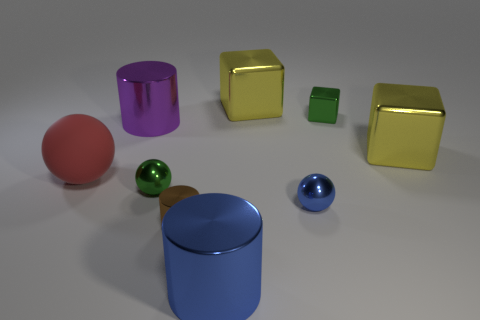Are there more small metal cubes that are right of the small shiny block than cylinders behind the large blue cylinder?
Your answer should be very brief. No. How many large red objects have the same material as the large blue cylinder?
Your answer should be very brief. 0. Do the matte object and the brown cylinder have the same size?
Offer a very short reply. No. The tiny cube is what color?
Provide a short and direct response. Green. What number of objects are yellow shiny objects or small brown objects?
Give a very brief answer. 3. Is there a big blue rubber object of the same shape as the large red rubber thing?
Provide a succinct answer. No. There is a small shiny object that is behind the big red rubber thing; does it have the same color as the big rubber object?
Offer a terse response. No. The green object behind the small green shiny ball that is in front of the large purple metallic cylinder is what shape?
Your answer should be compact. Cube. Is there a gray cube of the same size as the brown metallic object?
Ensure brevity in your answer.  No. Is the number of green spheres less than the number of tiny yellow rubber cylinders?
Ensure brevity in your answer.  No. 